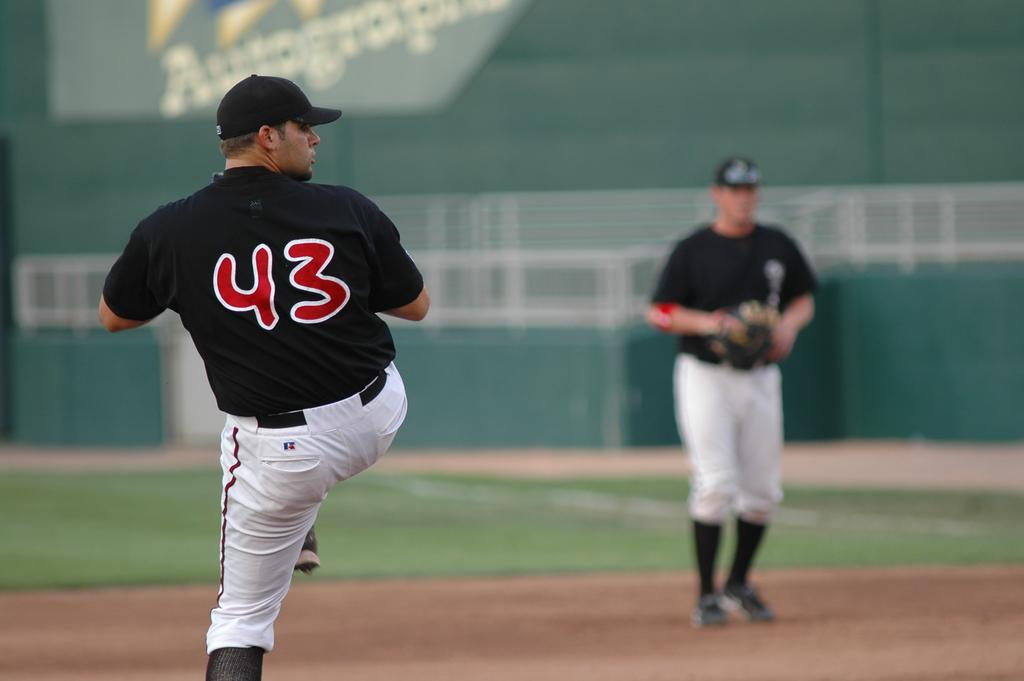<image>
Share a concise interpretation of the image provided. The player wearing 43 is about to pitch a ball. 